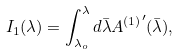<formula> <loc_0><loc_0><loc_500><loc_500>I _ { 1 } ( \lambda ) = \int ^ { \lambda } _ { \lambda _ { o } } d \bar { \lambda } { A ^ { ( 1 ) } } ^ { \prime } ( \bar { \lambda } ) ,</formula> 